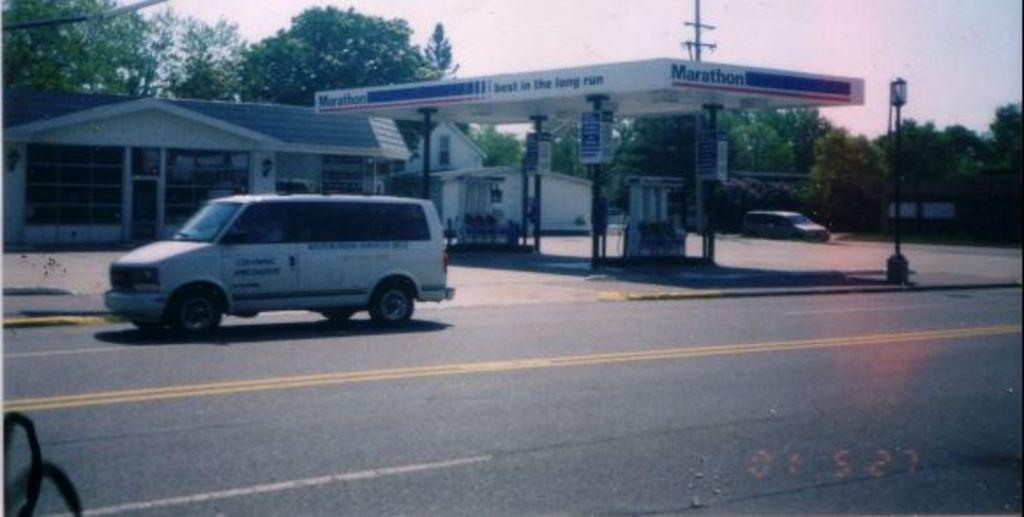What types of objects are present in the image? There are vehicles and light poles in the image. What can be seen in the background of the image? There is a house, a petrol bunk, and trees with green color in the background of the image. What is the color of the sky in the image? The sky is white in color. What type of liquid can be seen flowing from the jellyfish in the image? There are no jellyfish present in the image, so it is not possible to determine if any liquid is flowing from them. 